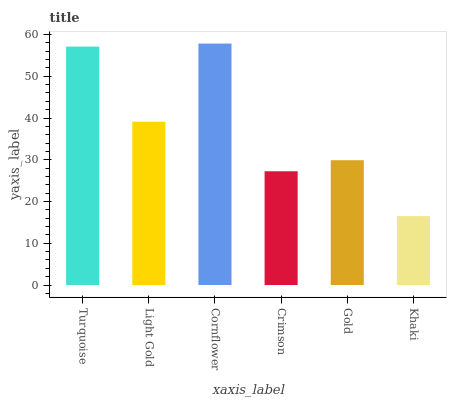Is Khaki the minimum?
Answer yes or no. Yes. Is Cornflower the maximum?
Answer yes or no. Yes. Is Light Gold the minimum?
Answer yes or no. No. Is Light Gold the maximum?
Answer yes or no. No. Is Turquoise greater than Light Gold?
Answer yes or no. Yes. Is Light Gold less than Turquoise?
Answer yes or no. Yes. Is Light Gold greater than Turquoise?
Answer yes or no. No. Is Turquoise less than Light Gold?
Answer yes or no. No. Is Light Gold the high median?
Answer yes or no. Yes. Is Gold the low median?
Answer yes or no. Yes. Is Turquoise the high median?
Answer yes or no. No. Is Cornflower the low median?
Answer yes or no. No. 